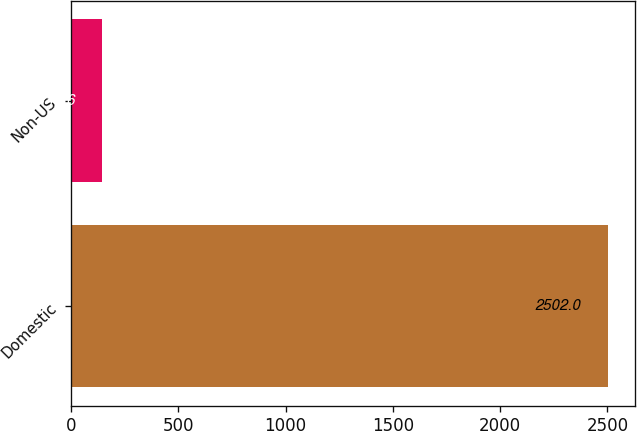<chart> <loc_0><loc_0><loc_500><loc_500><bar_chart><fcel>Domestic<fcel>Non-US<nl><fcel>2502<fcel>143.6<nl></chart> 